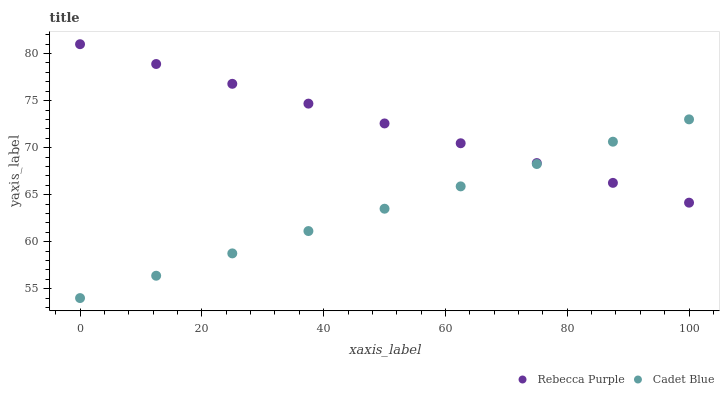Does Cadet Blue have the minimum area under the curve?
Answer yes or no. Yes. Does Rebecca Purple have the maximum area under the curve?
Answer yes or no. Yes. Does Rebecca Purple have the minimum area under the curve?
Answer yes or no. No. Is Cadet Blue the smoothest?
Answer yes or no. Yes. Is Rebecca Purple the roughest?
Answer yes or no. Yes. Is Rebecca Purple the smoothest?
Answer yes or no. No. Does Cadet Blue have the lowest value?
Answer yes or no. Yes. Does Rebecca Purple have the lowest value?
Answer yes or no. No. Does Rebecca Purple have the highest value?
Answer yes or no. Yes. Does Cadet Blue intersect Rebecca Purple?
Answer yes or no. Yes. Is Cadet Blue less than Rebecca Purple?
Answer yes or no. No. Is Cadet Blue greater than Rebecca Purple?
Answer yes or no. No. 